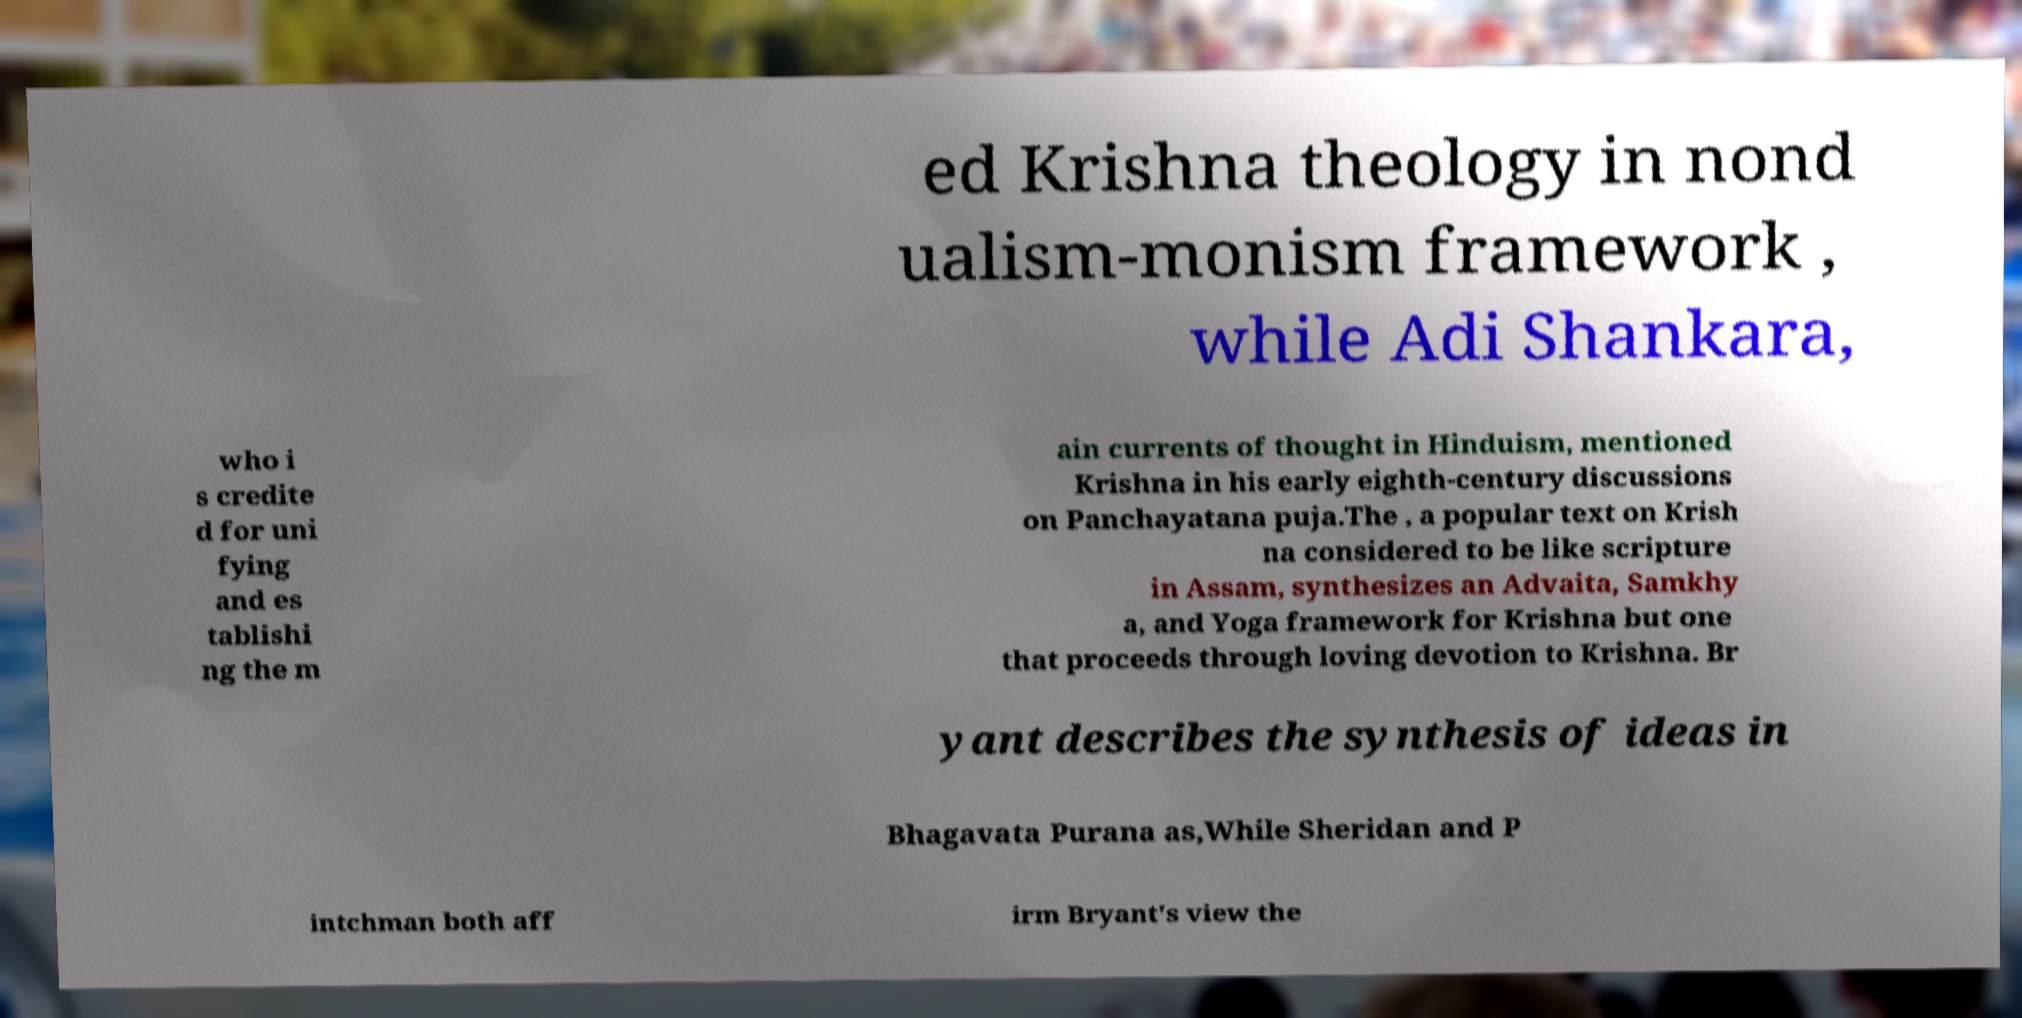Can you read and provide the text displayed in the image?This photo seems to have some interesting text. Can you extract and type it out for me? ed Krishna theology in nond ualism-monism framework , while Adi Shankara, who i s credite d for uni fying and es tablishi ng the m ain currents of thought in Hinduism, mentioned Krishna in his early eighth-century discussions on Panchayatana puja.The , a popular text on Krish na considered to be like scripture in Assam, synthesizes an Advaita, Samkhy a, and Yoga framework for Krishna but one that proceeds through loving devotion to Krishna. Br yant describes the synthesis of ideas in Bhagavata Purana as,While Sheridan and P intchman both aff irm Bryant's view the 